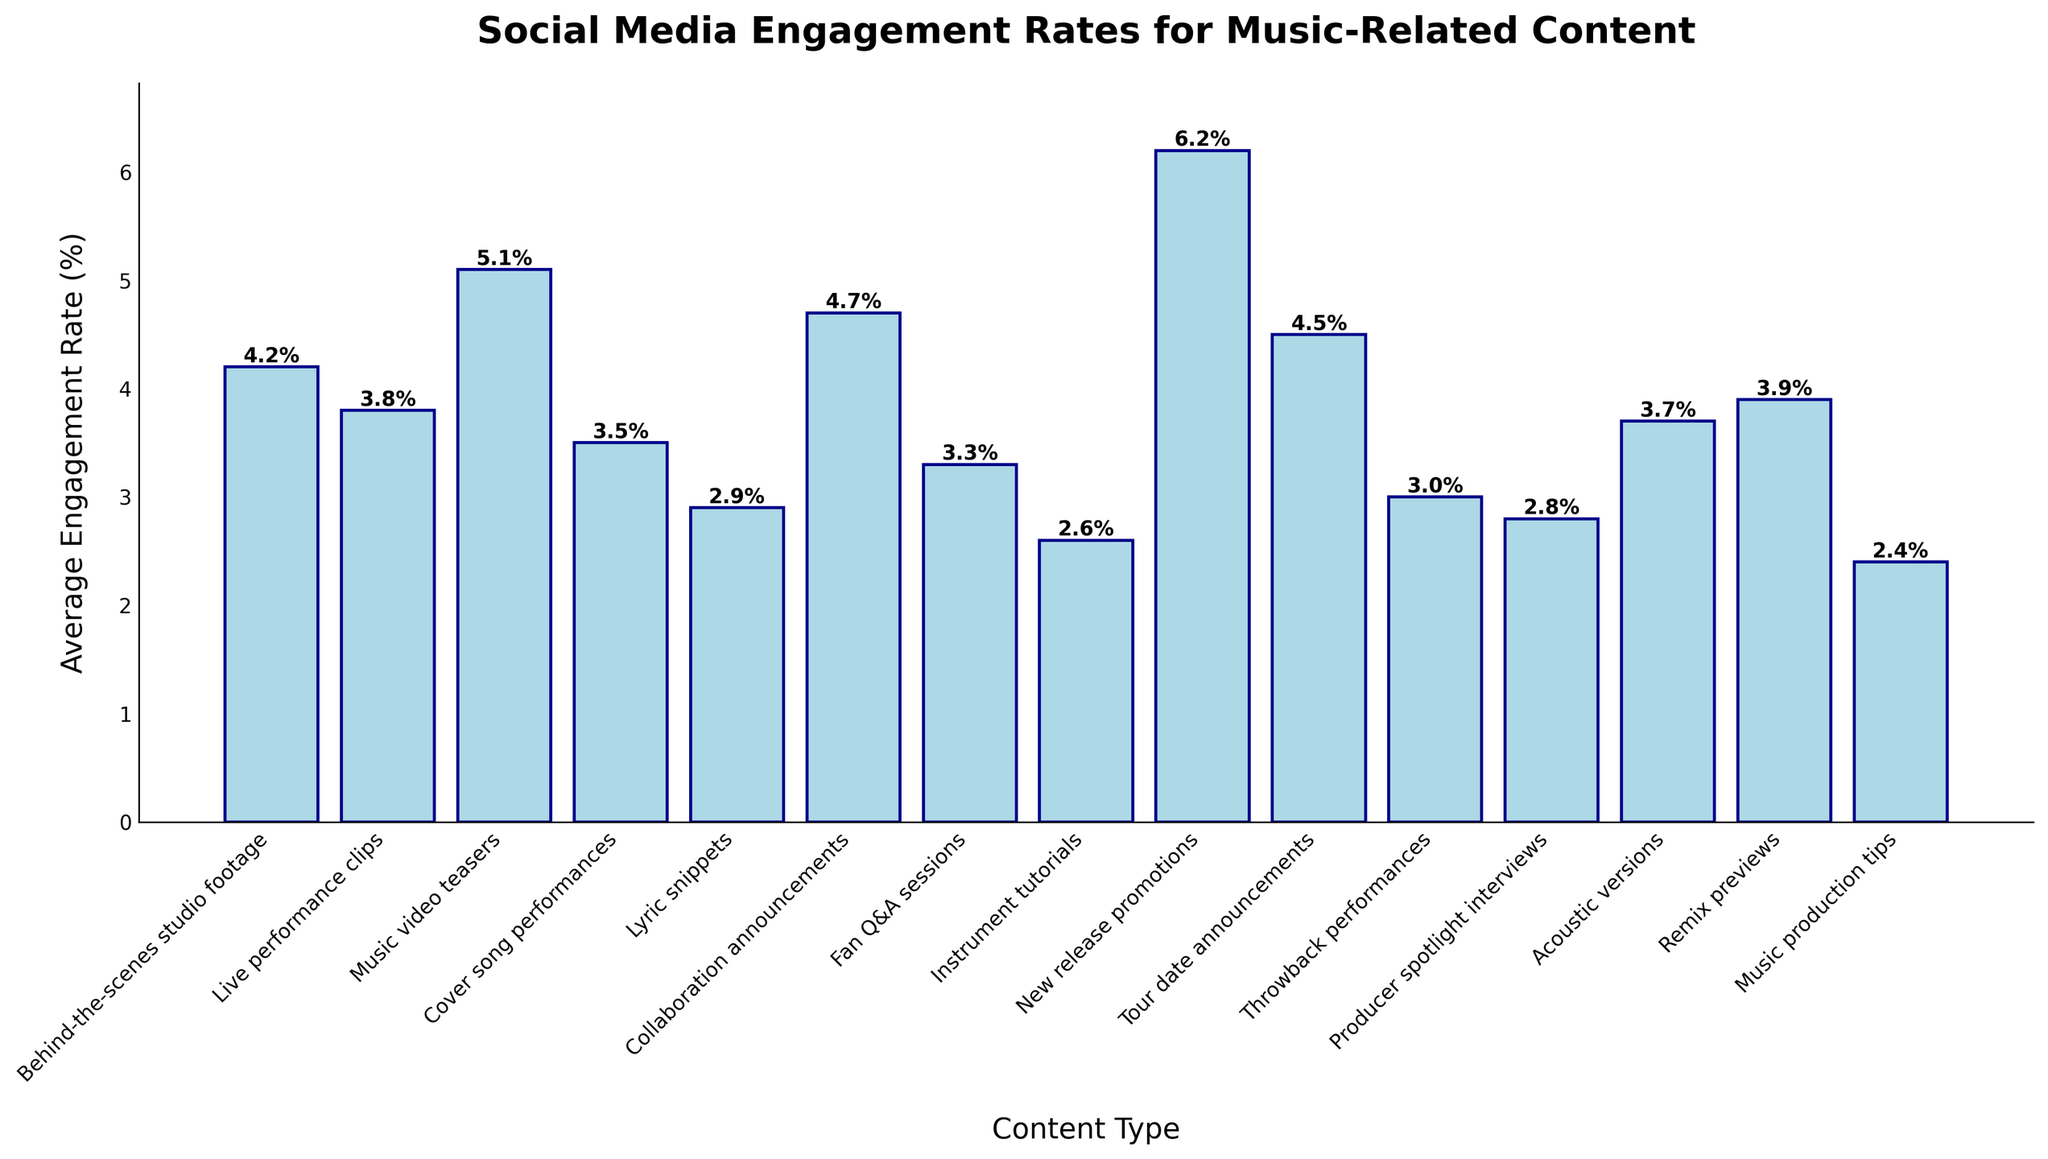What type of music-related content has the highest average engagement rate? First, locate the bar with the highest height in the chart. The content type associated with this bar will have the highest engagement rate, which is 'New release promotions' with a rate of 6.2%.
Answer: New release promotions Which two content types have the lowest average engagement rates? Identify the lowest two bars in the chart. The content types corresponding to these bars are 'Music production tips' and 'Instrument tutorials', with engagement rates of 2.4% and 2.6% respectively.
Answer: Music production tips and Instrument tutorials Which content type has a higher average engagement rate: 'Live performance clips' or 'Cover song performances'? Compare the heights of the bars for 'Live performance clips' and 'Cover song performances'. 'Live performance clips' has an engagement rate of 3.8%, which is higher than the 3.5% for 'Cover song performances'.
Answer: Live performance clips What is the total average engagement rate when combining 'Collaboration announcements' and 'Tour date announcements'? Sum the engagement rates of 'Collaboration announcements' (4.7%) and 'Tour date announcements' (4.5%). The total is 4.7 + 4.5 = 9.2.
Answer: 9.2 What is the average engagement rate of the top three highest-rated content types? Identify and sum the engagement rates of the top three content types, which are 'New release promotions' (6.2%), 'Music video teasers' (5.1%), and 'Collaboration announcements' (4.7%). The sum is 6.2 + 5.1 + 4.7 = 16. Then, divide by 3 to find the average: 16 / 3 ≈ 5.33.
Answer: 5.33 Which content types have engagement rates above 4%? Identify the bars with heights above the 4% mark. The content types are 'Behind-the-scenes studio footage', 'Music video teasers', 'Collaboration announcements', 'New release promotions', and 'Tour date announcements'.
Answer: Behind-the-scenes studio footage, Music video teasers, Collaboration announcements, New release promotions, Tour date announcements Is the engagement rate of 'Remix previews' greater than the combined engagement rate of 'Producer spotlight interviews' and 'Lyric snippets'? The engagement rate for 'Remix previews' is 3.9%. Sum the engagement rates for 'Producer spotlight interviews' (2.8%) and 'Lyric snippets' (2.9%), resulting in 2.8 + 2.9 = 5.7. Since 3.9% is less than 5.7%, the answer is no.
Answer: No How does the engagement rate for 'Acoustic versions' compare to the engagement rate for 'Fan Q&A sessions'? Compare the heights of the bars for 'Acoustic versions' (3.7%) and 'Fan Q&A sessions' (3.3%). 'Acoustic versions' has a higher engagement rate.
Answer: Acoustic versions 